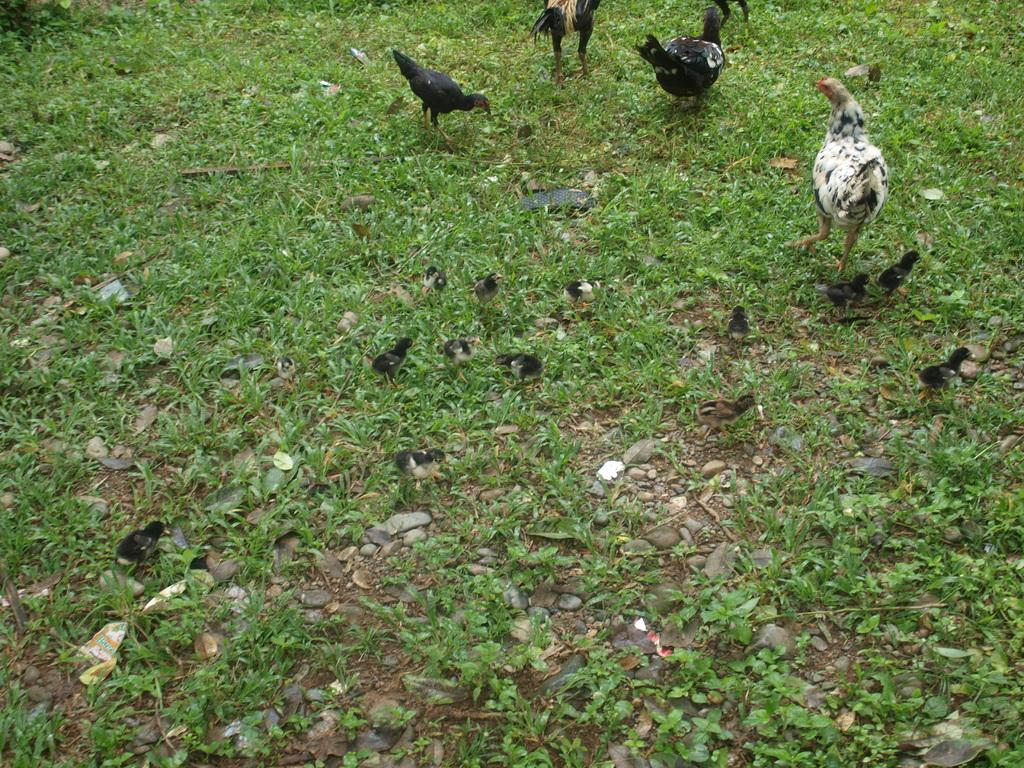What type of animals are present in the image? There are hens and chicks in the image. What is the environment like in the image? There is grass at the bottom of the image. What type of machine can be seen operating in the background of the image? There is no machine present in the image; it features hens, chicks, and grass. What is the mass of the largest hen in the image? It is not possible to determine the mass of the hens from the image alone. 